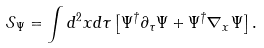Convert formula to latex. <formula><loc_0><loc_0><loc_500><loc_500>\mathcal { S } _ { \Psi } = \int d ^ { 2 } x d \tau \left [ \Psi ^ { \dagger } \partial _ { \tau } \Psi + \Psi ^ { \dagger } \nabla _ { x } \Psi \right ] .</formula> 